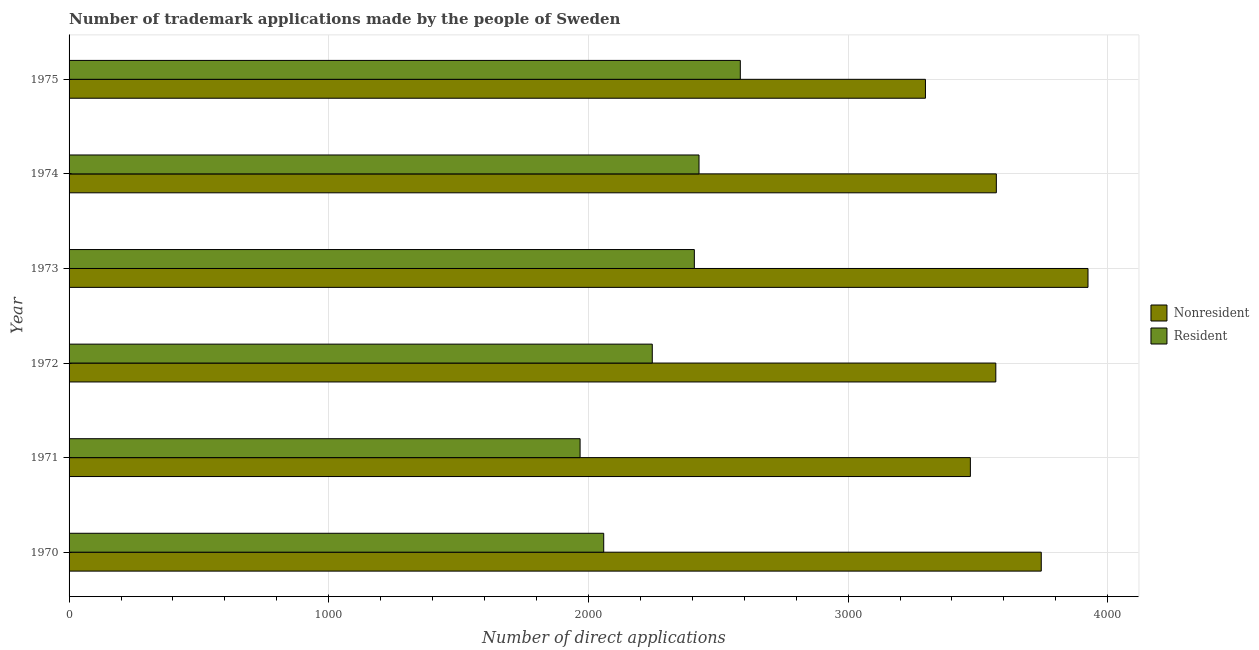Are the number of bars per tick equal to the number of legend labels?
Give a very brief answer. Yes. Are the number of bars on each tick of the Y-axis equal?
Ensure brevity in your answer.  Yes. How many bars are there on the 3rd tick from the top?
Provide a short and direct response. 2. What is the label of the 1st group of bars from the top?
Your answer should be compact. 1975. What is the number of trademark applications made by non residents in 1972?
Give a very brief answer. 3569. Across all years, what is the maximum number of trademark applications made by non residents?
Offer a very short reply. 3924. Across all years, what is the minimum number of trademark applications made by residents?
Your response must be concise. 1968. In which year was the number of trademark applications made by residents maximum?
Provide a short and direct response. 1975. What is the total number of trademark applications made by non residents in the graph?
Keep it short and to the point. 2.16e+04. What is the difference between the number of trademark applications made by non residents in 1973 and that in 1975?
Provide a short and direct response. 626. What is the difference between the number of trademark applications made by non residents in 1972 and the number of trademark applications made by residents in 1970?
Make the answer very short. 1510. What is the average number of trademark applications made by non residents per year?
Your response must be concise. 3596.17. In the year 1975, what is the difference between the number of trademark applications made by non residents and number of trademark applications made by residents?
Ensure brevity in your answer.  713. In how many years, is the number of trademark applications made by non residents greater than 1200 ?
Offer a terse response. 6. What is the ratio of the number of trademark applications made by non residents in 1973 to that in 1974?
Offer a very short reply. 1.1. Is the difference between the number of trademark applications made by residents in 1970 and 1974 greater than the difference between the number of trademark applications made by non residents in 1970 and 1974?
Keep it short and to the point. No. What is the difference between the highest and the second highest number of trademark applications made by non residents?
Give a very brief answer. 180. What is the difference between the highest and the lowest number of trademark applications made by residents?
Give a very brief answer. 617. What does the 1st bar from the top in 1970 represents?
Offer a terse response. Resident. What does the 2nd bar from the bottom in 1974 represents?
Make the answer very short. Resident. Are all the bars in the graph horizontal?
Make the answer very short. Yes. How many years are there in the graph?
Offer a terse response. 6. What is the difference between two consecutive major ticks on the X-axis?
Your answer should be compact. 1000. Does the graph contain grids?
Provide a succinct answer. Yes. How many legend labels are there?
Ensure brevity in your answer.  2. How are the legend labels stacked?
Your answer should be very brief. Vertical. What is the title of the graph?
Your answer should be very brief. Number of trademark applications made by the people of Sweden. What is the label or title of the X-axis?
Your answer should be very brief. Number of direct applications. What is the label or title of the Y-axis?
Provide a short and direct response. Year. What is the Number of direct applications of Nonresident in 1970?
Ensure brevity in your answer.  3744. What is the Number of direct applications in Resident in 1970?
Your response must be concise. 2059. What is the Number of direct applications in Nonresident in 1971?
Provide a succinct answer. 3471. What is the Number of direct applications in Resident in 1971?
Ensure brevity in your answer.  1968. What is the Number of direct applications in Nonresident in 1972?
Your answer should be very brief. 3569. What is the Number of direct applications of Resident in 1972?
Provide a short and direct response. 2246. What is the Number of direct applications in Nonresident in 1973?
Ensure brevity in your answer.  3924. What is the Number of direct applications in Resident in 1973?
Give a very brief answer. 2408. What is the Number of direct applications of Nonresident in 1974?
Make the answer very short. 3571. What is the Number of direct applications of Resident in 1974?
Your response must be concise. 2426. What is the Number of direct applications of Nonresident in 1975?
Keep it short and to the point. 3298. What is the Number of direct applications in Resident in 1975?
Offer a terse response. 2585. Across all years, what is the maximum Number of direct applications of Nonresident?
Provide a succinct answer. 3924. Across all years, what is the maximum Number of direct applications of Resident?
Ensure brevity in your answer.  2585. Across all years, what is the minimum Number of direct applications in Nonresident?
Your response must be concise. 3298. Across all years, what is the minimum Number of direct applications of Resident?
Your answer should be compact. 1968. What is the total Number of direct applications of Nonresident in the graph?
Offer a terse response. 2.16e+04. What is the total Number of direct applications of Resident in the graph?
Your response must be concise. 1.37e+04. What is the difference between the Number of direct applications in Nonresident in 1970 and that in 1971?
Make the answer very short. 273. What is the difference between the Number of direct applications in Resident in 1970 and that in 1971?
Offer a terse response. 91. What is the difference between the Number of direct applications in Nonresident in 1970 and that in 1972?
Offer a terse response. 175. What is the difference between the Number of direct applications of Resident in 1970 and that in 1972?
Keep it short and to the point. -187. What is the difference between the Number of direct applications in Nonresident in 1970 and that in 1973?
Your answer should be very brief. -180. What is the difference between the Number of direct applications of Resident in 1970 and that in 1973?
Make the answer very short. -349. What is the difference between the Number of direct applications in Nonresident in 1970 and that in 1974?
Keep it short and to the point. 173. What is the difference between the Number of direct applications in Resident in 1970 and that in 1974?
Make the answer very short. -367. What is the difference between the Number of direct applications in Nonresident in 1970 and that in 1975?
Your answer should be compact. 446. What is the difference between the Number of direct applications of Resident in 1970 and that in 1975?
Offer a very short reply. -526. What is the difference between the Number of direct applications in Nonresident in 1971 and that in 1972?
Keep it short and to the point. -98. What is the difference between the Number of direct applications of Resident in 1971 and that in 1972?
Ensure brevity in your answer.  -278. What is the difference between the Number of direct applications of Nonresident in 1971 and that in 1973?
Your answer should be compact. -453. What is the difference between the Number of direct applications in Resident in 1971 and that in 1973?
Your answer should be compact. -440. What is the difference between the Number of direct applications in Nonresident in 1971 and that in 1974?
Give a very brief answer. -100. What is the difference between the Number of direct applications of Resident in 1971 and that in 1974?
Your response must be concise. -458. What is the difference between the Number of direct applications in Nonresident in 1971 and that in 1975?
Make the answer very short. 173. What is the difference between the Number of direct applications in Resident in 1971 and that in 1975?
Your response must be concise. -617. What is the difference between the Number of direct applications of Nonresident in 1972 and that in 1973?
Your answer should be compact. -355. What is the difference between the Number of direct applications in Resident in 1972 and that in 1973?
Make the answer very short. -162. What is the difference between the Number of direct applications of Resident in 1972 and that in 1974?
Give a very brief answer. -180. What is the difference between the Number of direct applications of Nonresident in 1972 and that in 1975?
Offer a terse response. 271. What is the difference between the Number of direct applications of Resident in 1972 and that in 1975?
Your response must be concise. -339. What is the difference between the Number of direct applications in Nonresident in 1973 and that in 1974?
Your answer should be compact. 353. What is the difference between the Number of direct applications of Resident in 1973 and that in 1974?
Provide a succinct answer. -18. What is the difference between the Number of direct applications in Nonresident in 1973 and that in 1975?
Offer a terse response. 626. What is the difference between the Number of direct applications in Resident in 1973 and that in 1975?
Your answer should be compact. -177. What is the difference between the Number of direct applications in Nonresident in 1974 and that in 1975?
Give a very brief answer. 273. What is the difference between the Number of direct applications of Resident in 1974 and that in 1975?
Keep it short and to the point. -159. What is the difference between the Number of direct applications in Nonresident in 1970 and the Number of direct applications in Resident in 1971?
Make the answer very short. 1776. What is the difference between the Number of direct applications in Nonresident in 1970 and the Number of direct applications in Resident in 1972?
Provide a short and direct response. 1498. What is the difference between the Number of direct applications in Nonresident in 1970 and the Number of direct applications in Resident in 1973?
Your response must be concise. 1336. What is the difference between the Number of direct applications of Nonresident in 1970 and the Number of direct applications of Resident in 1974?
Your response must be concise. 1318. What is the difference between the Number of direct applications of Nonresident in 1970 and the Number of direct applications of Resident in 1975?
Ensure brevity in your answer.  1159. What is the difference between the Number of direct applications of Nonresident in 1971 and the Number of direct applications of Resident in 1972?
Make the answer very short. 1225. What is the difference between the Number of direct applications in Nonresident in 1971 and the Number of direct applications in Resident in 1973?
Make the answer very short. 1063. What is the difference between the Number of direct applications of Nonresident in 1971 and the Number of direct applications of Resident in 1974?
Keep it short and to the point. 1045. What is the difference between the Number of direct applications of Nonresident in 1971 and the Number of direct applications of Resident in 1975?
Keep it short and to the point. 886. What is the difference between the Number of direct applications in Nonresident in 1972 and the Number of direct applications in Resident in 1973?
Provide a succinct answer. 1161. What is the difference between the Number of direct applications of Nonresident in 1972 and the Number of direct applications of Resident in 1974?
Offer a terse response. 1143. What is the difference between the Number of direct applications of Nonresident in 1972 and the Number of direct applications of Resident in 1975?
Your answer should be very brief. 984. What is the difference between the Number of direct applications in Nonresident in 1973 and the Number of direct applications in Resident in 1974?
Your answer should be compact. 1498. What is the difference between the Number of direct applications of Nonresident in 1973 and the Number of direct applications of Resident in 1975?
Offer a terse response. 1339. What is the difference between the Number of direct applications of Nonresident in 1974 and the Number of direct applications of Resident in 1975?
Provide a succinct answer. 986. What is the average Number of direct applications of Nonresident per year?
Make the answer very short. 3596.17. What is the average Number of direct applications of Resident per year?
Offer a very short reply. 2282. In the year 1970, what is the difference between the Number of direct applications of Nonresident and Number of direct applications of Resident?
Your answer should be compact. 1685. In the year 1971, what is the difference between the Number of direct applications in Nonresident and Number of direct applications in Resident?
Your answer should be very brief. 1503. In the year 1972, what is the difference between the Number of direct applications of Nonresident and Number of direct applications of Resident?
Make the answer very short. 1323. In the year 1973, what is the difference between the Number of direct applications of Nonresident and Number of direct applications of Resident?
Offer a terse response. 1516. In the year 1974, what is the difference between the Number of direct applications in Nonresident and Number of direct applications in Resident?
Your response must be concise. 1145. In the year 1975, what is the difference between the Number of direct applications of Nonresident and Number of direct applications of Resident?
Offer a very short reply. 713. What is the ratio of the Number of direct applications of Nonresident in 1970 to that in 1971?
Your answer should be compact. 1.08. What is the ratio of the Number of direct applications in Resident in 1970 to that in 1971?
Your response must be concise. 1.05. What is the ratio of the Number of direct applications in Nonresident in 1970 to that in 1972?
Give a very brief answer. 1.05. What is the ratio of the Number of direct applications in Nonresident in 1970 to that in 1973?
Ensure brevity in your answer.  0.95. What is the ratio of the Number of direct applications of Resident in 1970 to that in 1973?
Provide a succinct answer. 0.86. What is the ratio of the Number of direct applications of Nonresident in 1970 to that in 1974?
Provide a succinct answer. 1.05. What is the ratio of the Number of direct applications in Resident in 1970 to that in 1974?
Ensure brevity in your answer.  0.85. What is the ratio of the Number of direct applications in Nonresident in 1970 to that in 1975?
Offer a terse response. 1.14. What is the ratio of the Number of direct applications in Resident in 1970 to that in 1975?
Your answer should be compact. 0.8. What is the ratio of the Number of direct applications in Nonresident in 1971 to that in 1972?
Offer a terse response. 0.97. What is the ratio of the Number of direct applications of Resident in 1971 to that in 1972?
Provide a short and direct response. 0.88. What is the ratio of the Number of direct applications of Nonresident in 1971 to that in 1973?
Offer a terse response. 0.88. What is the ratio of the Number of direct applications in Resident in 1971 to that in 1973?
Your response must be concise. 0.82. What is the ratio of the Number of direct applications in Nonresident in 1971 to that in 1974?
Your response must be concise. 0.97. What is the ratio of the Number of direct applications in Resident in 1971 to that in 1974?
Give a very brief answer. 0.81. What is the ratio of the Number of direct applications of Nonresident in 1971 to that in 1975?
Your answer should be very brief. 1.05. What is the ratio of the Number of direct applications in Resident in 1971 to that in 1975?
Make the answer very short. 0.76. What is the ratio of the Number of direct applications in Nonresident in 1972 to that in 1973?
Make the answer very short. 0.91. What is the ratio of the Number of direct applications of Resident in 1972 to that in 1973?
Your answer should be compact. 0.93. What is the ratio of the Number of direct applications in Nonresident in 1972 to that in 1974?
Make the answer very short. 1. What is the ratio of the Number of direct applications of Resident in 1972 to that in 1974?
Your answer should be compact. 0.93. What is the ratio of the Number of direct applications of Nonresident in 1972 to that in 1975?
Offer a very short reply. 1.08. What is the ratio of the Number of direct applications of Resident in 1972 to that in 1975?
Keep it short and to the point. 0.87. What is the ratio of the Number of direct applications of Nonresident in 1973 to that in 1974?
Make the answer very short. 1.1. What is the ratio of the Number of direct applications of Resident in 1973 to that in 1974?
Ensure brevity in your answer.  0.99. What is the ratio of the Number of direct applications of Nonresident in 1973 to that in 1975?
Give a very brief answer. 1.19. What is the ratio of the Number of direct applications of Resident in 1973 to that in 1975?
Offer a terse response. 0.93. What is the ratio of the Number of direct applications of Nonresident in 1974 to that in 1975?
Offer a very short reply. 1.08. What is the ratio of the Number of direct applications of Resident in 1974 to that in 1975?
Ensure brevity in your answer.  0.94. What is the difference between the highest and the second highest Number of direct applications in Nonresident?
Ensure brevity in your answer.  180. What is the difference between the highest and the second highest Number of direct applications in Resident?
Make the answer very short. 159. What is the difference between the highest and the lowest Number of direct applications in Nonresident?
Make the answer very short. 626. What is the difference between the highest and the lowest Number of direct applications of Resident?
Provide a succinct answer. 617. 